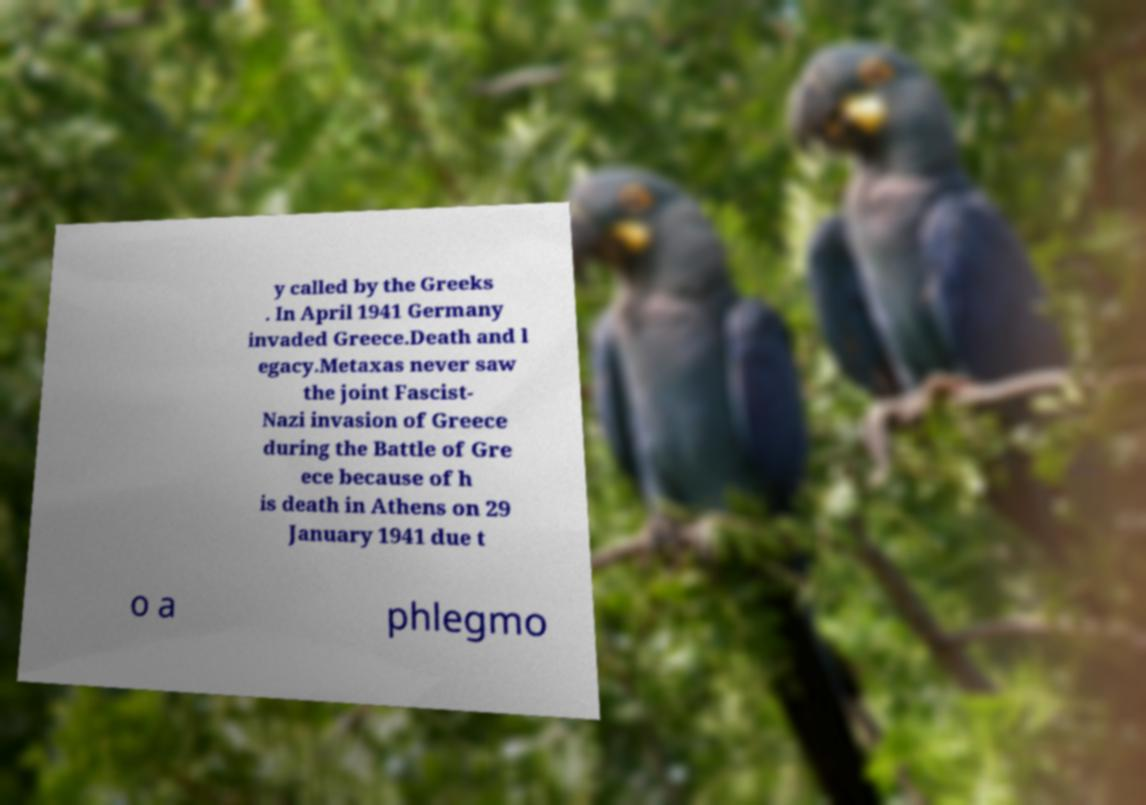Can you read and provide the text displayed in the image?This photo seems to have some interesting text. Can you extract and type it out for me? y called by the Greeks . In April 1941 Germany invaded Greece.Death and l egacy.Metaxas never saw the joint Fascist- Nazi invasion of Greece during the Battle of Gre ece because of h is death in Athens on 29 January 1941 due t o a phlegmo 